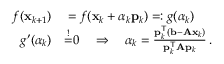<formula> <loc_0><loc_0><loc_500><loc_500>\begin{array} { r l } { f ( x _ { k + 1 } ) } & = f ( x _ { k } + \alpha _ { k } p _ { k } ) = \colon g ( \alpha _ { k } ) } \\ { g ^ { \prime } ( \alpha _ { k } ) } & { \overset { ! } { = } } 0 \quad \Rightarrow \quad \alpha _ { k } = { \frac { p _ { k } ^ { T } ( b - A x _ { k } ) } { p _ { k } ^ { T } A p _ { k } } } \, . } \end{array}</formula> 